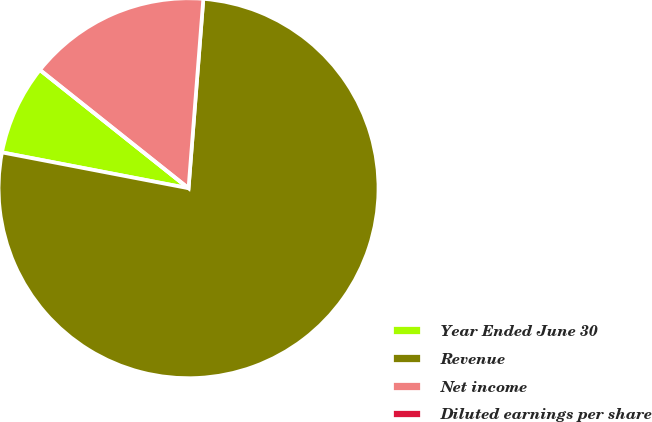<chart> <loc_0><loc_0><loc_500><loc_500><pie_chart><fcel>Year Ended June 30<fcel>Revenue<fcel>Net income<fcel>Diluted earnings per share<nl><fcel>7.68%<fcel>76.78%<fcel>15.54%<fcel>0.0%<nl></chart> 